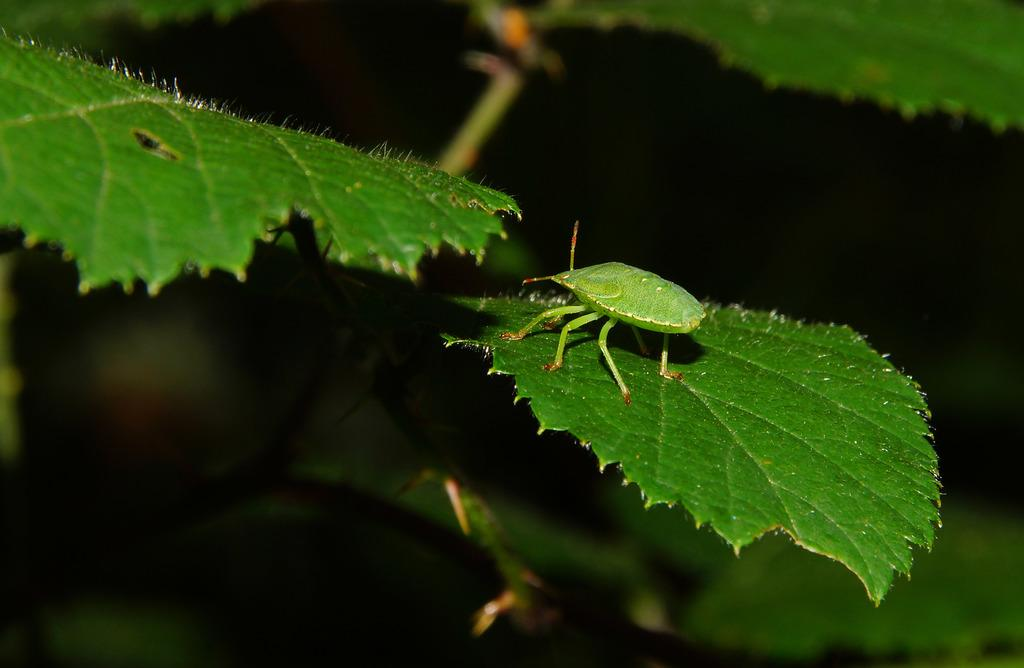What is on the leaf in the image? There is a bug on a leaf in the image. What can be seen in the background of the image? There is a plant in the background of the image. What type of crown is the clam wearing in the image? There is no clam or crown present in the image; it features a bug on a leaf and a plant in the background. 